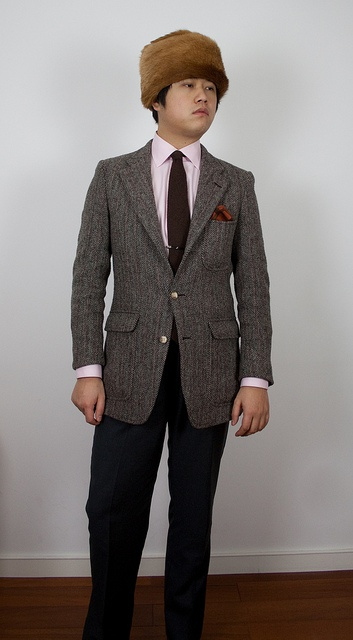Describe the objects in this image and their specific colors. I can see people in lightgray, black, gray, and maroon tones and tie in lightgray, black, gray, and darkgray tones in this image. 